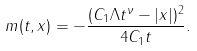Convert formula to latex. <formula><loc_0><loc_0><loc_500><loc_500>m ( t , x ) = - \frac { ( C _ { 1 } \Lambda t ^ { \nu } - | x | ) ^ { 2 } } { 4 C _ { 1 } t } .</formula> 